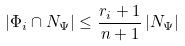Convert formula to latex. <formula><loc_0><loc_0><loc_500><loc_500>\left | \Phi _ { i } \cap N _ { \Psi } \right | \leq \frac { r _ { i } + 1 } { n + 1 } \left | N _ { \Psi } \right |</formula> 